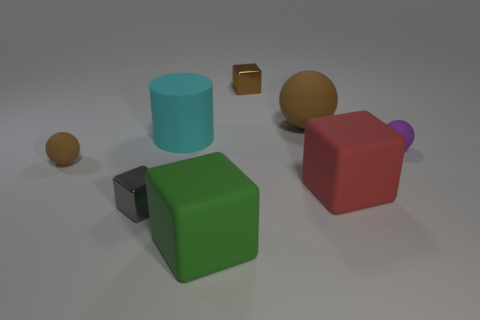What is the shape of the red rubber thing that is the same size as the cyan matte object?
Ensure brevity in your answer.  Cube. How many objects are either big cylinders or brown matte things that are left of the gray shiny thing?
Your answer should be very brief. 2. There is a purple rubber object that is behind the tiny cube that is in front of the large red object; what number of tiny purple rubber balls are behind it?
Offer a terse response. 0. There is a big cylinder that is made of the same material as the green block; what is its color?
Provide a short and direct response. Cyan. There is a brown ball on the left side of the gray thing; is it the same size as the brown metal cube?
Provide a succinct answer. Yes. How many objects are big spheres or metal cubes?
Your response must be concise. 3. The brown object that is in front of the small matte ball that is on the right side of the tiny thing that is behind the cyan matte thing is made of what material?
Offer a very short reply. Rubber. There is a small sphere that is to the left of the big brown matte ball; what material is it?
Provide a short and direct response. Rubber. Is there a purple block of the same size as the gray block?
Ensure brevity in your answer.  No. There is a metal object behind the large red matte thing; does it have the same color as the rubber cylinder?
Keep it short and to the point. No. 